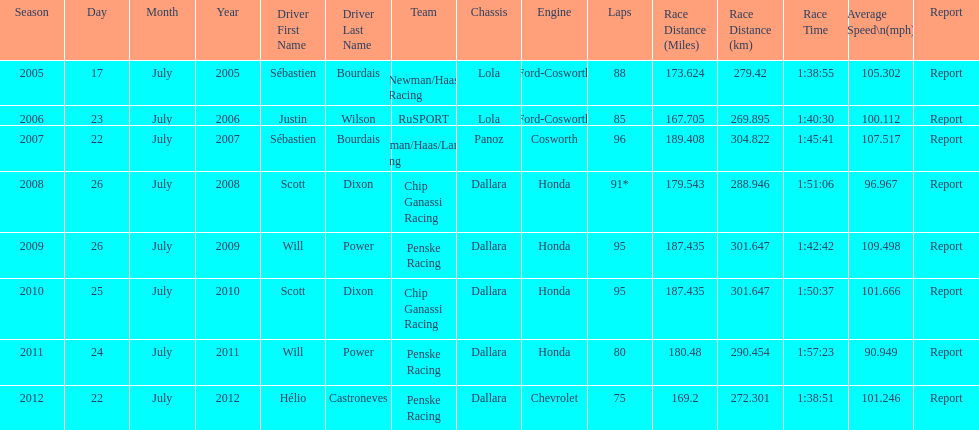Was the average speed in the year 2011 of the indycar series above or below the average speed of the year before? Below. I'm looking to parse the entire table for insights. Could you assist me with that? {'header': ['Season', 'Day', 'Month', 'Year', 'Driver First Name', 'Driver Last Name', 'Team', 'Chassis', 'Engine', 'Laps', 'Race Distance (Miles)', 'Race Distance (km)', 'Race Time', 'Average Speed\\n(mph)', 'Report'], 'rows': [['2005', '17', 'July', '2005', 'Sébastien', 'Bourdais', 'Newman/Haas Racing', 'Lola', 'Ford-Cosworth', '88', '173.624', '279.42', '1:38:55', '105.302', 'Report'], ['2006', '23', 'July', '2006', 'Justin', 'Wilson', 'RuSPORT', 'Lola', 'Ford-Cosworth', '85', '167.705', '269.895', '1:40:30', '100.112', 'Report'], ['2007', '22', 'July', '2007', 'Sébastien', 'Bourdais', 'Newman/Haas/Lanigan Racing', 'Panoz', 'Cosworth', '96', '189.408', '304.822', '1:45:41', '107.517', 'Report'], ['2008', '26', 'July', '2008', 'Scott', 'Dixon', 'Chip Ganassi Racing', 'Dallara', 'Honda', '91*', '179.543', '288.946', '1:51:06', '96.967', 'Report'], ['2009', '26', 'July', '2009', 'Will', 'Power', 'Penske Racing', 'Dallara', 'Honda', '95', '187.435', '301.647', '1:42:42', '109.498', 'Report'], ['2010', '25', 'July', '2010', 'Scott', 'Dixon', 'Chip Ganassi Racing', 'Dallara', 'Honda', '95', '187.435', '301.647', '1:50:37', '101.666', 'Report'], ['2011', '24', 'July', '2011', 'Will', 'Power', 'Penske Racing', 'Dallara', 'Honda', '80', '180.48', '290.454', '1:57:23', '90.949', 'Report'], ['2012', '22', 'July', '2012', 'Hélio', 'Castroneves', 'Penske Racing', 'Dallara', 'Chevrolet', '75', '169.2', '272.301', '1:38:51', '101.246', 'Report']]} 